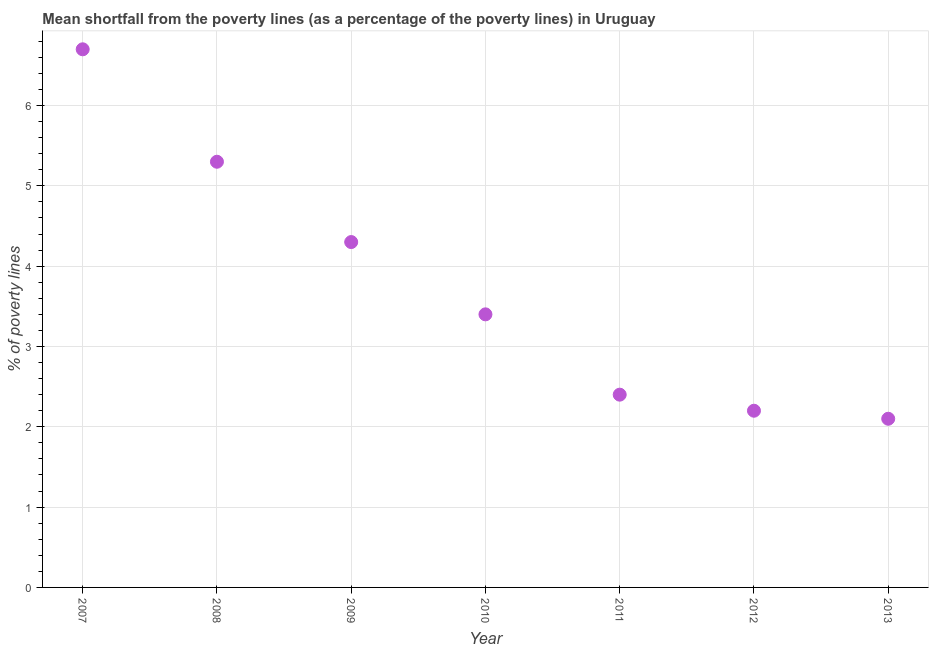What is the poverty gap at national poverty lines in 2008?
Your answer should be compact. 5.3. Across all years, what is the minimum poverty gap at national poverty lines?
Provide a short and direct response. 2.1. In which year was the poverty gap at national poverty lines maximum?
Your answer should be compact. 2007. In which year was the poverty gap at national poverty lines minimum?
Give a very brief answer. 2013. What is the sum of the poverty gap at national poverty lines?
Offer a very short reply. 26.4. What is the difference between the poverty gap at national poverty lines in 2010 and 2011?
Ensure brevity in your answer.  1. What is the average poverty gap at national poverty lines per year?
Give a very brief answer. 3.77. What is the median poverty gap at national poverty lines?
Your answer should be compact. 3.4. What is the ratio of the poverty gap at national poverty lines in 2011 to that in 2012?
Your answer should be very brief. 1.09. Is the poverty gap at national poverty lines in 2012 less than that in 2013?
Your answer should be compact. No. Is the difference between the poverty gap at national poverty lines in 2011 and 2013 greater than the difference between any two years?
Provide a short and direct response. No. What is the difference between the highest and the second highest poverty gap at national poverty lines?
Provide a succinct answer. 1.4. Is the sum of the poverty gap at national poverty lines in 2007 and 2010 greater than the maximum poverty gap at national poverty lines across all years?
Provide a succinct answer. Yes. Does the poverty gap at national poverty lines monotonically increase over the years?
Make the answer very short. No. How many dotlines are there?
Ensure brevity in your answer.  1. Does the graph contain any zero values?
Your response must be concise. No. What is the title of the graph?
Your answer should be very brief. Mean shortfall from the poverty lines (as a percentage of the poverty lines) in Uruguay. What is the label or title of the X-axis?
Keep it short and to the point. Year. What is the label or title of the Y-axis?
Give a very brief answer. % of poverty lines. What is the % of poverty lines in 2008?
Give a very brief answer. 5.3. What is the % of poverty lines in 2010?
Offer a terse response. 3.4. What is the % of poverty lines in 2011?
Give a very brief answer. 2.4. What is the % of poverty lines in 2012?
Your answer should be very brief. 2.2. What is the % of poverty lines in 2013?
Offer a very short reply. 2.1. What is the difference between the % of poverty lines in 2007 and 2009?
Offer a very short reply. 2.4. What is the difference between the % of poverty lines in 2007 and 2010?
Your answer should be compact. 3.3. What is the difference between the % of poverty lines in 2007 and 2012?
Ensure brevity in your answer.  4.5. What is the difference between the % of poverty lines in 2007 and 2013?
Ensure brevity in your answer.  4.6. What is the difference between the % of poverty lines in 2008 and 2009?
Keep it short and to the point. 1. What is the difference between the % of poverty lines in 2008 and 2013?
Provide a short and direct response. 3.2. What is the difference between the % of poverty lines in 2009 and 2010?
Provide a short and direct response. 0.9. What is the difference between the % of poverty lines in 2009 and 2012?
Your response must be concise. 2.1. What is the difference between the % of poverty lines in 2009 and 2013?
Provide a succinct answer. 2.2. What is the difference between the % of poverty lines in 2010 and 2011?
Your answer should be compact. 1. What is the difference between the % of poverty lines in 2010 and 2013?
Make the answer very short. 1.3. What is the difference between the % of poverty lines in 2011 and 2012?
Offer a very short reply. 0.2. What is the difference between the % of poverty lines in 2011 and 2013?
Keep it short and to the point. 0.3. What is the difference between the % of poverty lines in 2012 and 2013?
Offer a terse response. 0.1. What is the ratio of the % of poverty lines in 2007 to that in 2008?
Ensure brevity in your answer.  1.26. What is the ratio of the % of poverty lines in 2007 to that in 2009?
Keep it short and to the point. 1.56. What is the ratio of the % of poverty lines in 2007 to that in 2010?
Your answer should be very brief. 1.97. What is the ratio of the % of poverty lines in 2007 to that in 2011?
Make the answer very short. 2.79. What is the ratio of the % of poverty lines in 2007 to that in 2012?
Offer a very short reply. 3.04. What is the ratio of the % of poverty lines in 2007 to that in 2013?
Your answer should be compact. 3.19. What is the ratio of the % of poverty lines in 2008 to that in 2009?
Keep it short and to the point. 1.23. What is the ratio of the % of poverty lines in 2008 to that in 2010?
Ensure brevity in your answer.  1.56. What is the ratio of the % of poverty lines in 2008 to that in 2011?
Offer a terse response. 2.21. What is the ratio of the % of poverty lines in 2008 to that in 2012?
Your answer should be compact. 2.41. What is the ratio of the % of poverty lines in 2008 to that in 2013?
Give a very brief answer. 2.52. What is the ratio of the % of poverty lines in 2009 to that in 2010?
Provide a short and direct response. 1.26. What is the ratio of the % of poverty lines in 2009 to that in 2011?
Provide a succinct answer. 1.79. What is the ratio of the % of poverty lines in 2009 to that in 2012?
Provide a short and direct response. 1.96. What is the ratio of the % of poverty lines in 2009 to that in 2013?
Your answer should be compact. 2.05. What is the ratio of the % of poverty lines in 2010 to that in 2011?
Offer a terse response. 1.42. What is the ratio of the % of poverty lines in 2010 to that in 2012?
Your answer should be very brief. 1.54. What is the ratio of the % of poverty lines in 2010 to that in 2013?
Offer a terse response. 1.62. What is the ratio of the % of poverty lines in 2011 to that in 2012?
Offer a very short reply. 1.09. What is the ratio of the % of poverty lines in 2011 to that in 2013?
Ensure brevity in your answer.  1.14. What is the ratio of the % of poverty lines in 2012 to that in 2013?
Offer a terse response. 1.05. 